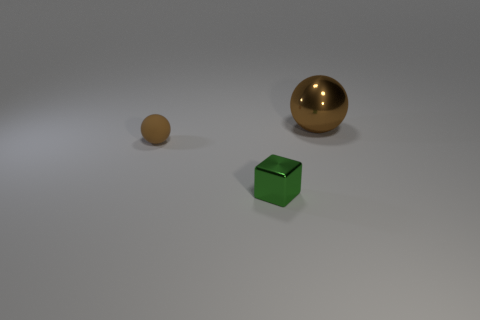There is a object that is right of the block; is its size the same as the small matte object?
Your answer should be very brief. No. What number of cylinders are green things or brown metal things?
Provide a succinct answer. 0. There is a object on the left side of the green shiny thing; what material is it?
Your answer should be compact. Rubber. Are there fewer matte balls than spheres?
Your answer should be compact. Yes. What size is the thing that is behind the shiny cube and to the left of the big brown metallic object?
Offer a terse response. Small. There is a brown sphere that is on the right side of the brown ball in front of the brown ball to the right of the tiny matte sphere; how big is it?
Offer a terse response. Large. What number of other objects are there of the same color as the matte object?
Ensure brevity in your answer.  1. There is a tiny thing that is on the left side of the small green object; does it have the same color as the small cube?
Provide a succinct answer. No. What number of things are big yellow shiny cubes or matte things?
Ensure brevity in your answer.  1. The object in front of the small matte sphere is what color?
Your answer should be compact. Green. 